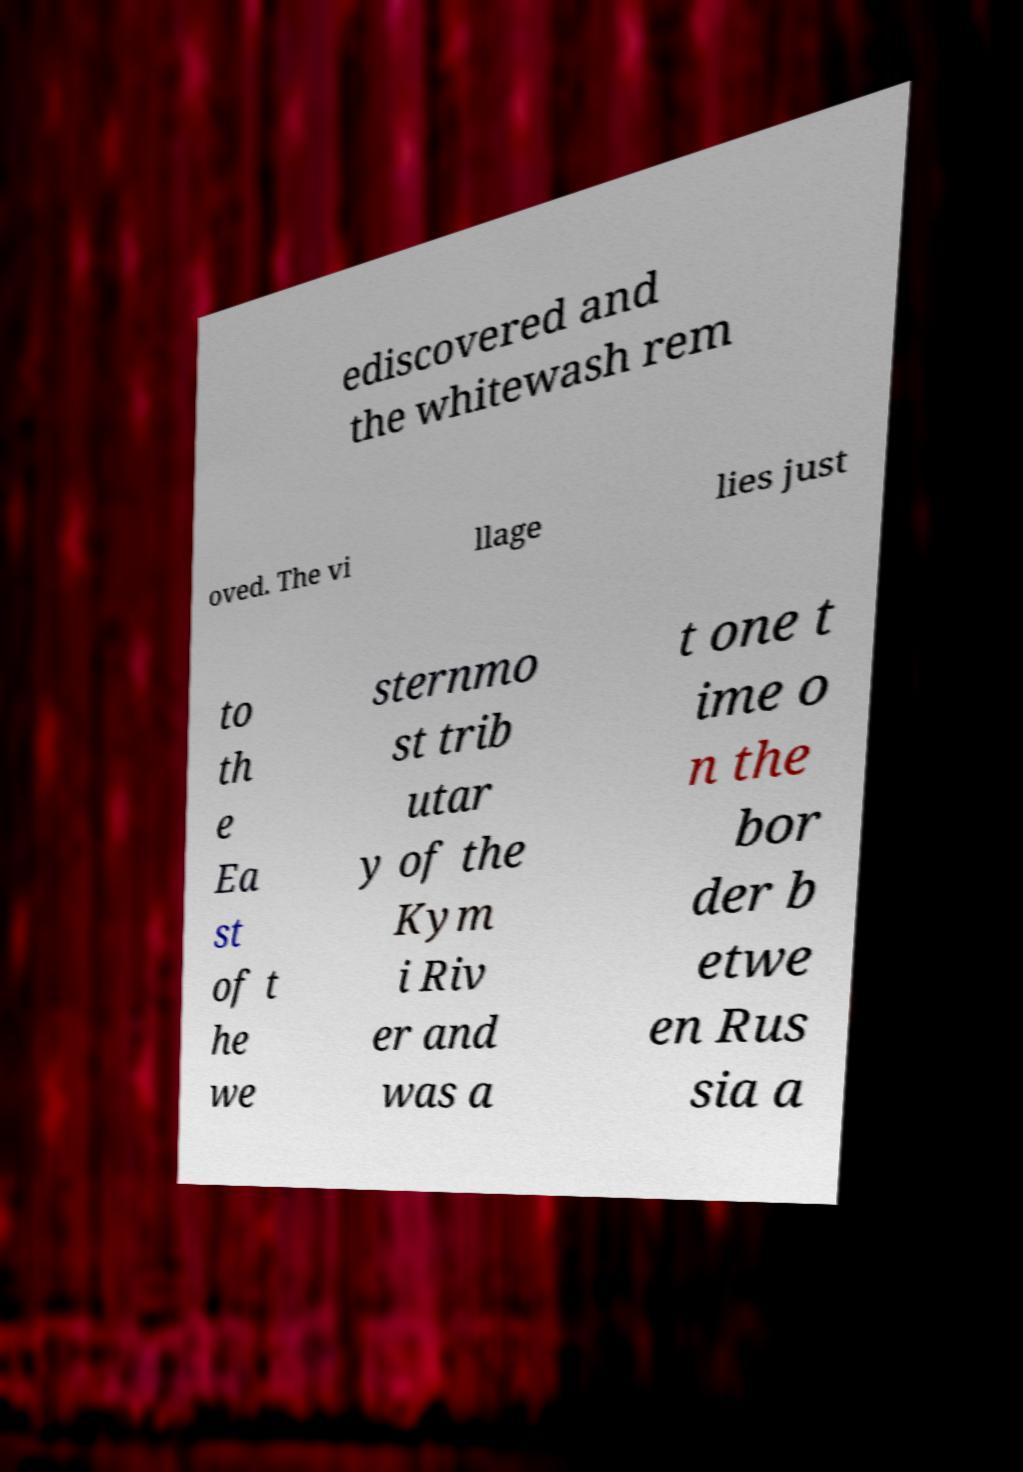Please read and relay the text visible in this image. What does it say? ediscovered and the whitewash rem oved. The vi llage lies just to th e Ea st of t he we sternmo st trib utar y of the Kym i Riv er and was a t one t ime o n the bor der b etwe en Rus sia a 